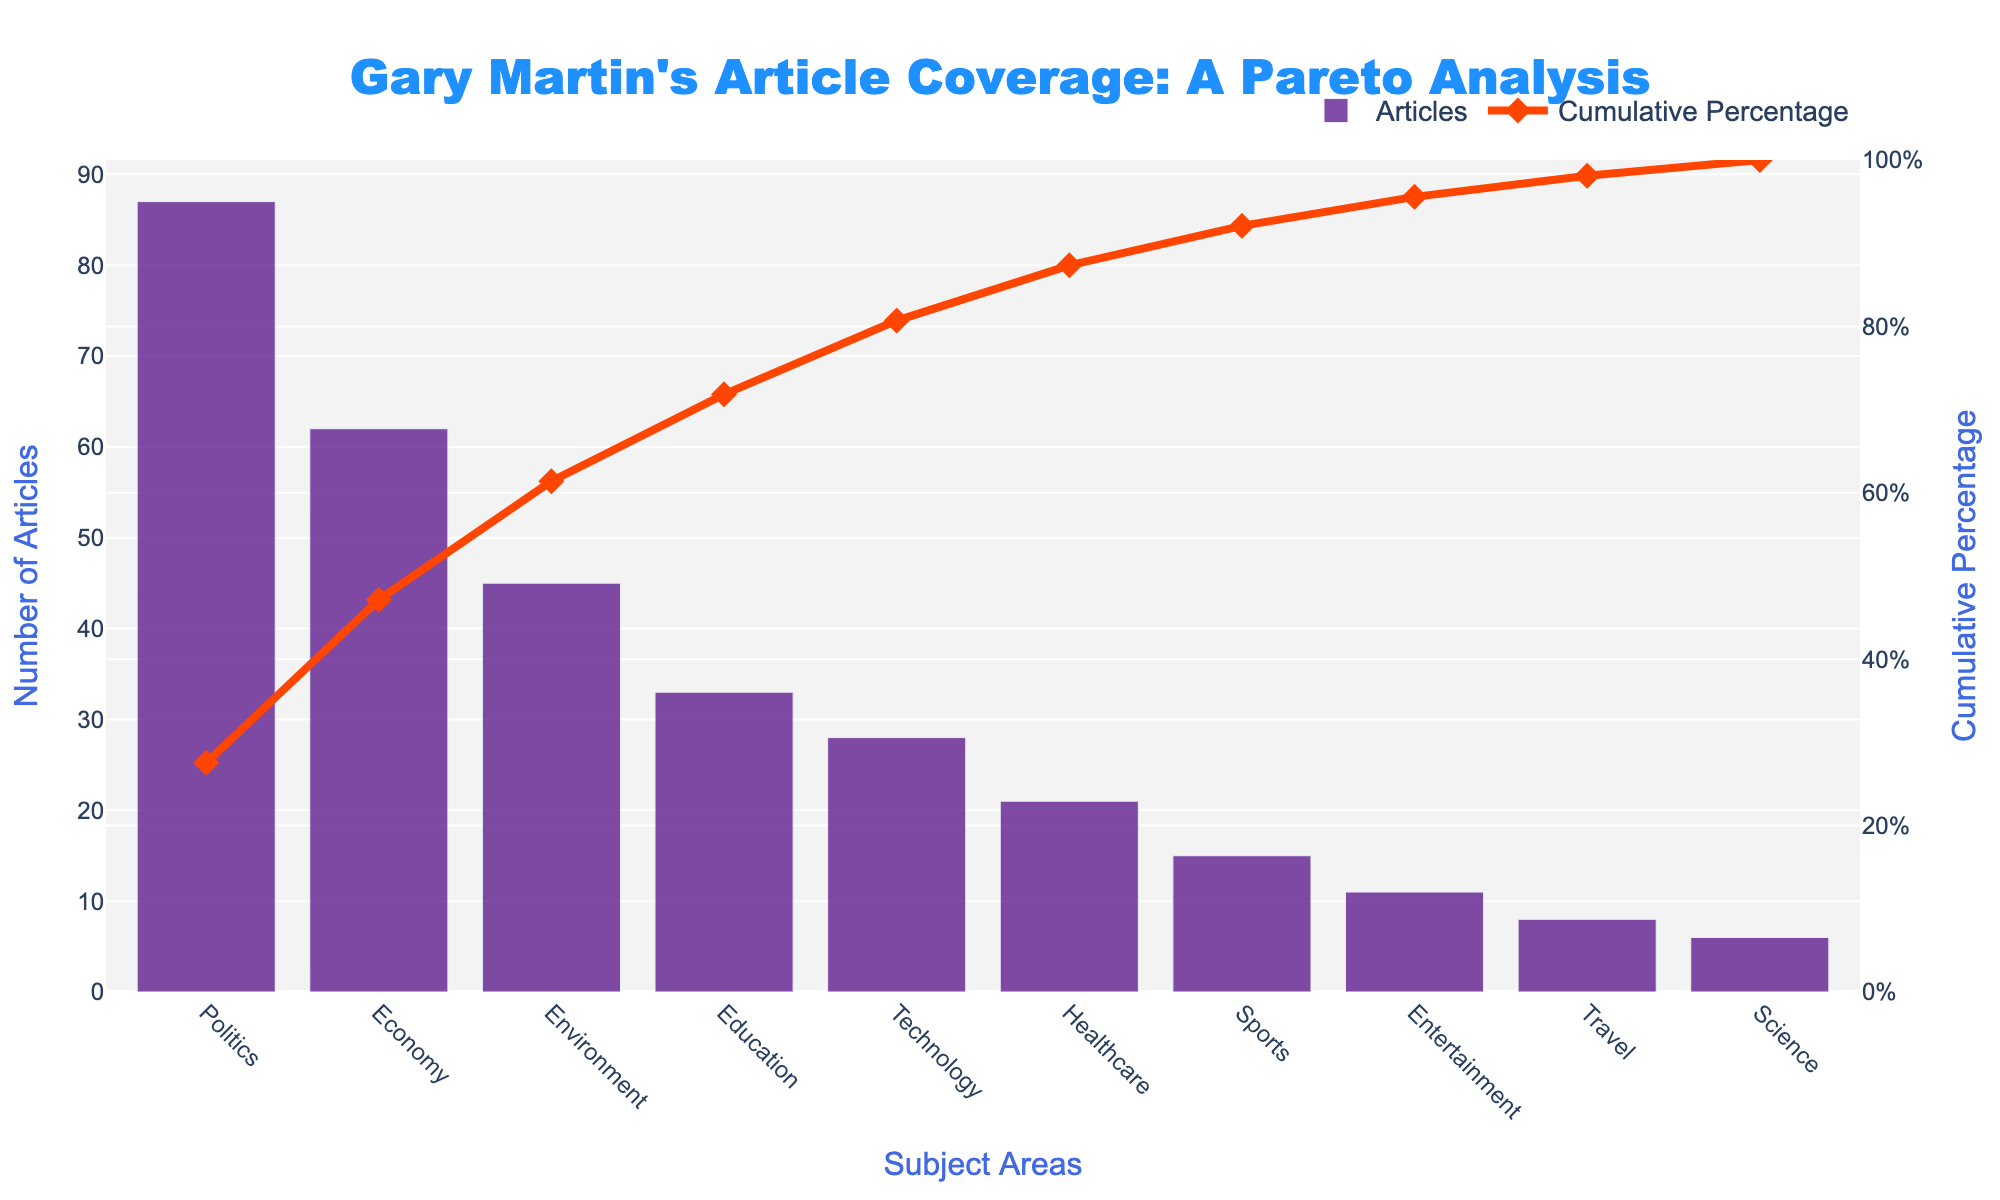How many subject areas are covered in Gary Martin's articles according to the Pareto chart? The chart shows multiple bars, each representing a different subject area. Counting the bars gives the number of subject areas covered.
Answer: 10 What is the title of the Pareto chart? The title of the chart is prominently displayed at the top. It reads: "Gary Martin's Article Coverage: A Pareto Analysis."
Answer: Gary Martin's Article Coverage: A Pareto Analysis Which subject has the maximum number of articles, and how many articles does it include? The tallest bar on the chart represents the subject with the maximum number of articles. The y-axis next to the tallest bar shows the count of articles.
Answer: Politics, 87 What percentage of Gary Martin's articles does the top two subject areas (Politics and Economy) cover cumulatively? To find the cumulative percentage, identify the values for Politics and Economy from the y-axis and sum them up, then refer to the cumulative percentage line for the summed value.
Answer: 64.89% Which subject marks the 80% cumulative coverage in Gary Martin's articles? Locate the 80% marker on the right y-axis (cumulative percentage) and trace it to the corresponding subject area on the x-axis.
Answer: Technology What is the color of the bar chart representing the number of articles? The color is visible in the bars on the chart; they are purple.
Answer: Purple What is the count difference between the subject with the highest number of articles and the one with the least number of articles? Identify the highest value (Politics, 87) and the lowest value (Science, 6) on the y-axis, then subtract the lowest from the highest.
Answer: 81 What subject areas have fewer than 20 articles? Identify bars on the chart with heights less than the marker for 20 on the y-axis and note the corresponding subjects on the x-axis.
Answer: Sports, Entertainment, Travel, Science What is the cumulative percentage after including articles on Healthcare? Find the cumulative percentage value on the line chart corresponding to the Healthcare subject on the x-axis.
Answer: 81.37% How many articles are there on Technology, and what percentage of the total articles does it represent? Identify the height of the bar for Technology on the y-axis to find the number of articles, then use the cumulative percentage line to find the percentage.
Answer: 28, 8.17% 